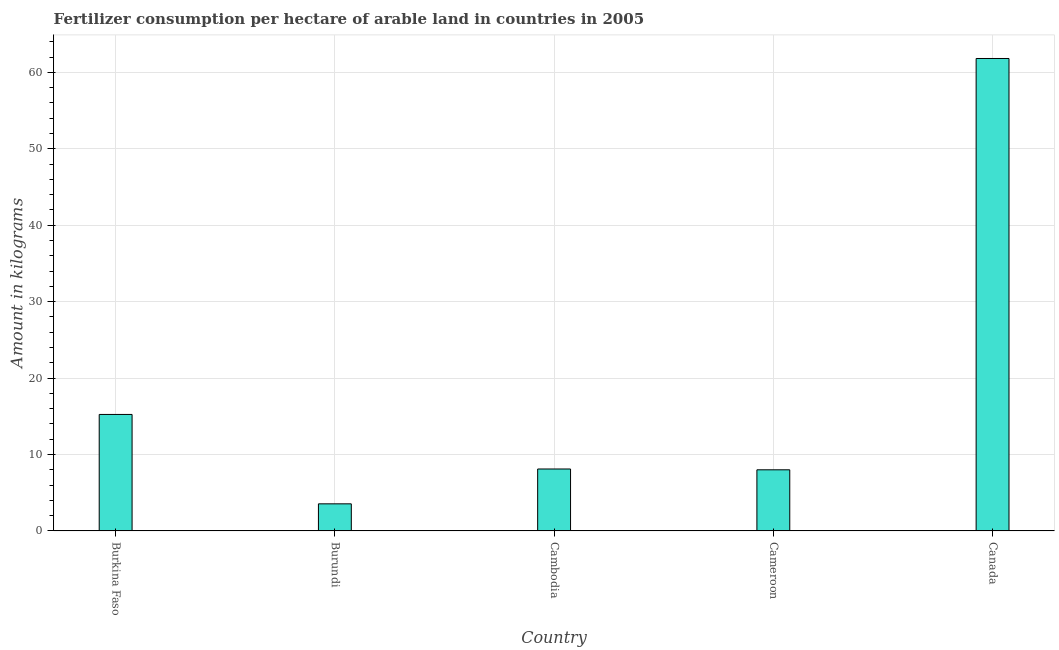What is the title of the graph?
Your response must be concise. Fertilizer consumption per hectare of arable land in countries in 2005 . What is the label or title of the Y-axis?
Your answer should be compact. Amount in kilograms. What is the amount of fertilizer consumption in Cameroon?
Make the answer very short. 8. Across all countries, what is the maximum amount of fertilizer consumption?
Offer a terse response. 61.82. Across all countries, what is the minimum amount of fertilizer consumption?
Provide a succinct answer. 3.55. In which country was the amount of fertilizer consumption minimum?
Provide a succinct answer. Burundi. What is the sum of the amount of fertilizer consumption?
Your response must be concise. 96.72. What is the difference between the amount of fertilizer consumption in Cambodia and Cameroon?
Offer a very short reply. 0.11. What is the average amount of fertilizer consumption per country?
Provide a succinct answer. 19.34. What is the median amount of fertilizer consumption?
Your answer should be very brief. 8.11. What is the ratio of the amount of fertilizer consumption in Burkina Faso to that in Cambodia?
Keep it short and to the point. 1.88. Is the amount of fertilizer consumption in Burkina Faso less than that in Cambodia?
Give a very brief answer. No. Is the difference between the amount of fertilizer consumption in Burundi and Canada greater than the difference between any two countries?
Ensure brevity in your answer.  Yes. What is the difference between the highest and the second highest amount of fertilizer consumption?
Your response must be concise. 46.58. Is the sum of the amount of fertilizer consumption in Cambodia and Canada greater than the maximum amount of fertilizer consumption across all countries?
Provide a short and direct response. Yes. What is the difference between the highest and the lowest amount of fertilizer consumption?
Ensure brevity in your answer.  58.28. How many bars are there?
Provide a short and direct response. 5. Are all the bars in the graph horizontal?
Offer a very short reply. No. How many countries are there in the graph?
Ensure brevity in your answer.  5. What is the difference between two consecutive major ticks on the Y-axis?
Offer a very short reply. 10. Are the values on the major ticks of Y-axis written in scientific E-notation?
Your response must be concise. No. What is the Amount in kilograms in Burkina Faso?
Give a very brief answer. 15.24. What is the Amount in kilograms in Burundi?
Your answer should be very brief. 3.55. What is the Amount in kilograms in Cambodia?
Make the answer very short. 8.11. What is the Amount in kilograms in Cameroon?
Your answer should be compact. 8. What is the Amount in kilograms in Canada?
Your answer should be compact. 61.82. What is the difference between the Amount in kilograms in Burkina Faso and Burundi?
Your response must be concise. 11.7. What is the difference between the Amount in kilograms in Burkina Faso and Cambodia?
Provide a succinct answer. 7.14. What is the difference between the Amount in kilograms in Burkina Faso and Cameroon?
Give a very brief answer. 7.24. What is the difference between the Amount in kilograms in Burkina Faso and Canada?
Ensure brevity in your answer.  -46.58. What is the difference between the Amount in kilograms in Burundi and Cambodia?
Offer a very short reply. -4.56. What is the difference between the Amount in kilograms in Burundi and Cameroon?
Your response must be concise. -4.45. What is the difference between the Amount in kilograms in Burundi and Canada?
Give a very brief answer. -58.28. What is the difference between the Amount in kilograms in Cambodia and Cameroon?
Provide a succinct answer. 0.11. What is the difference between the Amount in kilograms in Cambodia and Canada?
Give a very brief answer. -53.72. What is the difference between the Amount in kilograms in Cameroon and Canada?
Make the answer very short. -53.82. What is the ratio of the Amount in kilograms in Burkina Faso to that in Burundi?
Keep it short and to the point. 4.3. What is the ratio of the Amount in kilograms in Burkina Faso to that in Cambodia?
Give a very brief answer. 1.88. What is the ratio of the Amount in kilograms in Burkina Faso to that in Cameroon?
Make the answer very short. 1.91. What is the ratio of the Amount in kilograms in Burkina Faso to that in Canada?
Your answer should be compact. 0.25. What is the ratio of the Amount in kilograms in Burundi to that in Cambodia?
Provide a succinct answer. 0.44. What is the ratio of the Amount in kilograms in Burundi to that in Cameroon?
Provide a short and direct response. 0.44. What is the ratio of the Amount in kilograms in Burundi to that in Canada?
Ensure brevity in your answer.  0.06. What is the ratio of the Amount in kilograms in Cambodia to that in Canada?
Your response must be concise. 0.13. What is the ratio of the Amount in kilograms in Cameroon to that in Canada?
Offer a terse response. 0.13. 